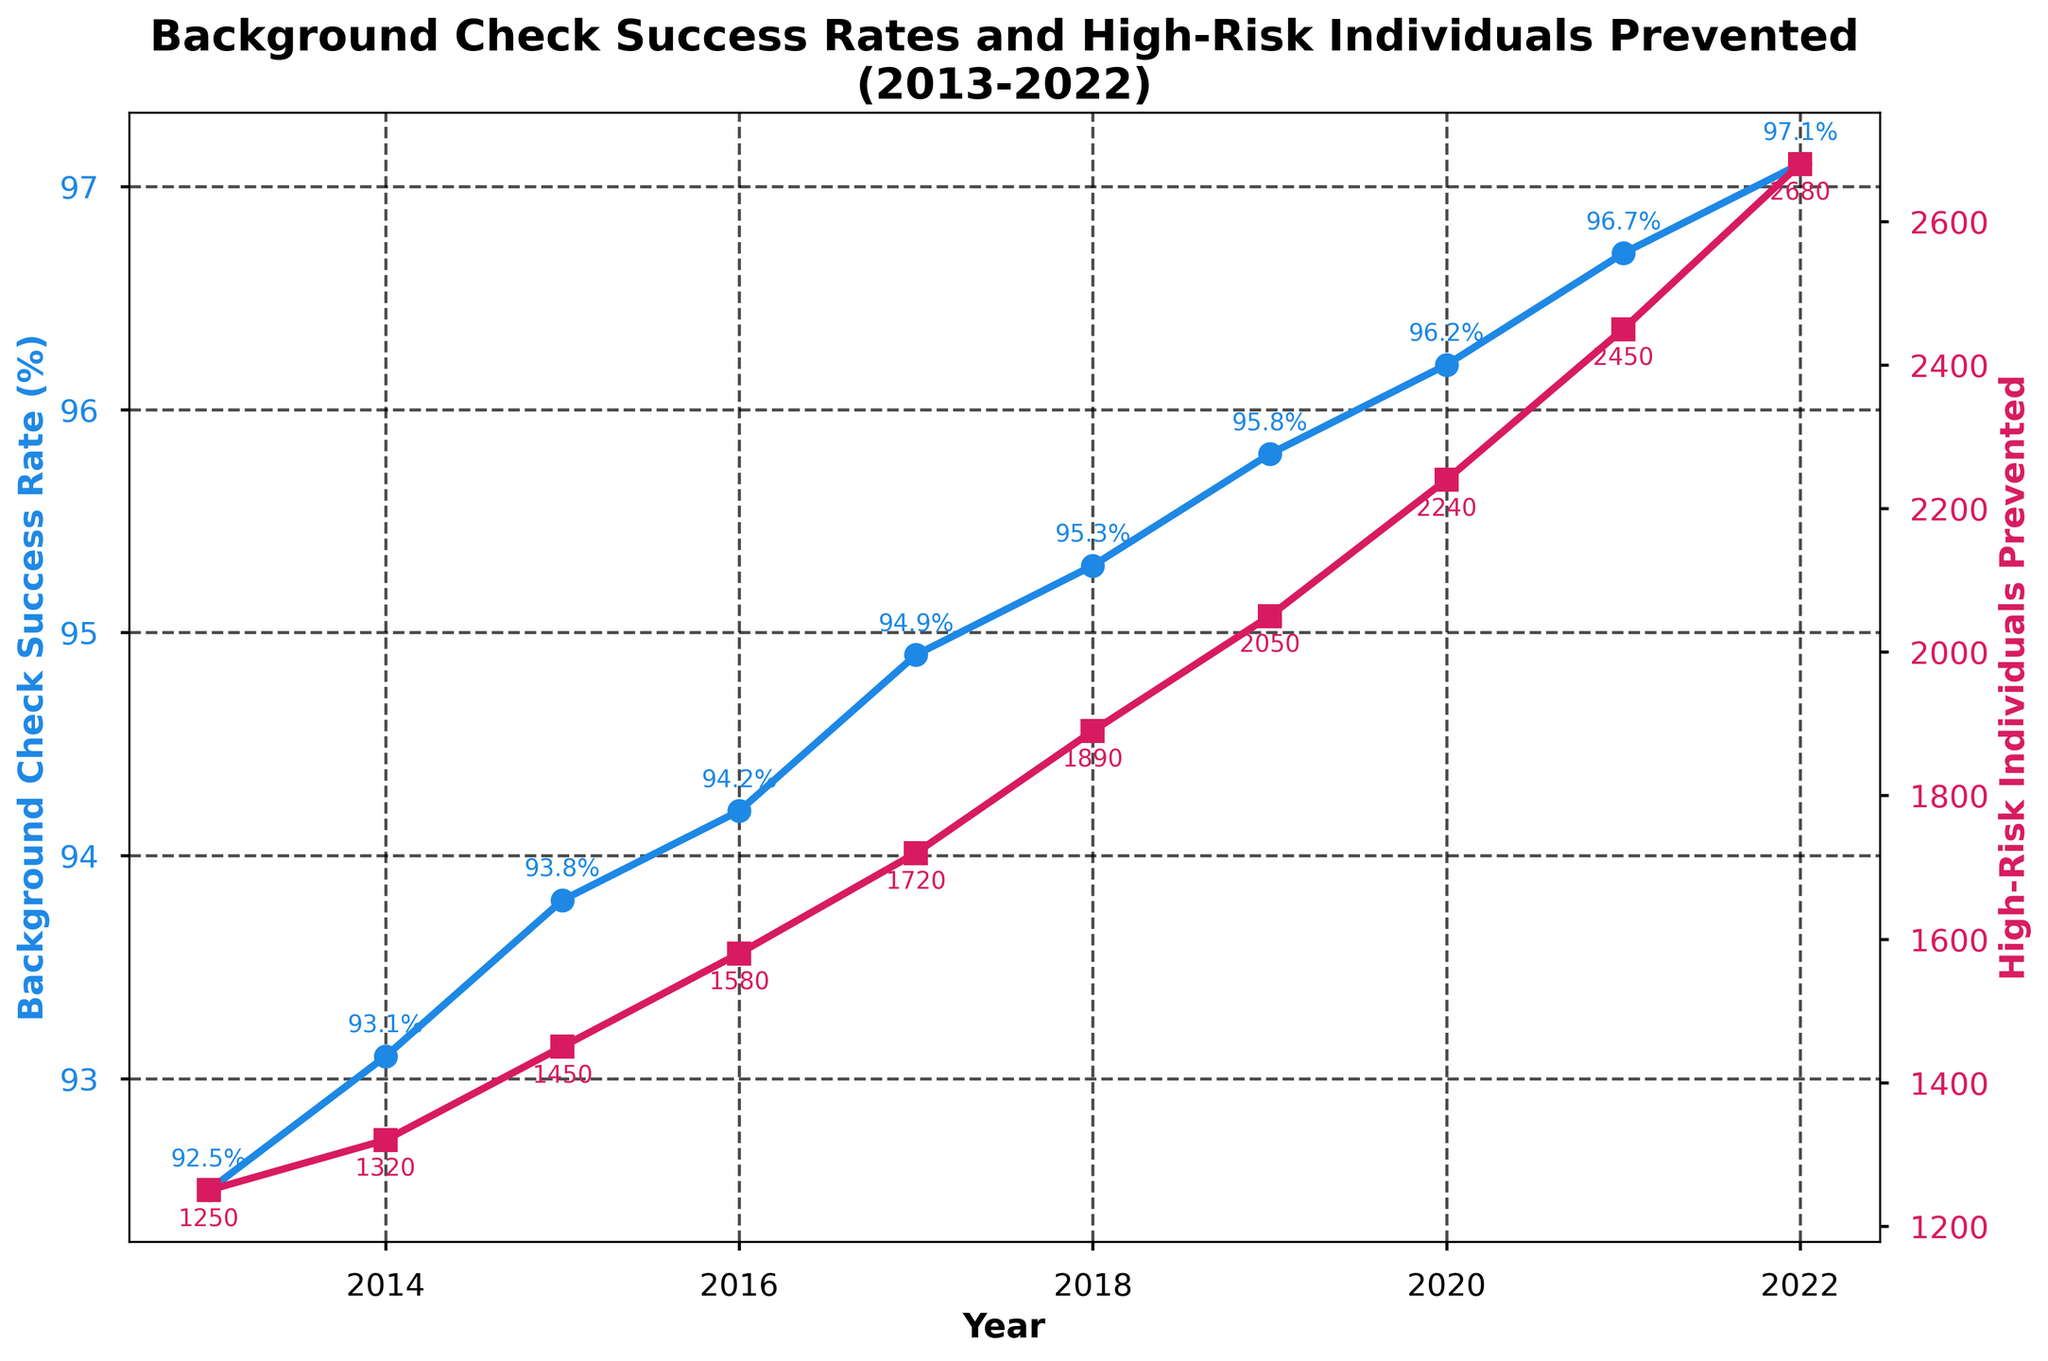What was the percentage success rate of background checks in 2017? The figure displays the background check success rates for each year marked with a blue line and circular markers. Looking at the year 2017, the success rate is marked by a blue point labeled 94.9%.
Answer: 94.9% How many high-risk individuals were prevented in 2020? The figure also plots the high-risk individuals prevented each year with a red line and square markers. For 2020, the value is indicated as 2240.
Answer: 2240 What was the difference in the number of high-risk individuals prevented between 2018 and 2022? First, identify the number of high-risk individuals prevented in 2018 (1890) and in 2022 (2680) from the red line. The difference is 2680 - 1890.
Answer: 790 How did the total number of high-risk individuals prevented change from 2013 to 2022? Review the red line's values for 2013 (1250) and 2022 (2680). Subtract the 2013 value from the 2022 value: 2680 - 1250.
Answer: Increased by 1430 What can be said about the trend in the success rate percentages from 2013 to 2022? The blue line plotting the success rates shows an upward trend, continuously increasing each year from 92.5% in 2013 to 97.1% in 2022.
Answer: Increasing trend Which year experienced the highest number of high-risk individuals prevented from purchasing guns? Refer to the red line plotting high-risk individuals prevented each year; the highest value is in 2022, marked as 2680.
Answer: 2022 Are there any years where the success rate remained constant? Checking each year's success rate on the blue line, we see that the rate continuously increases every year without remaining constant at any point.
Answer: No How does the percentage change in the background check success rate from 2013 to 2014 compare to the percentage change from 2020 to 2021? Calculate the percentage change for both intervals. For 2013-2014: (93.1 - 92.5)/92.5 * 100 = 0.649%, and for 2020-2021: (96.7 - 96.2)/96.2 * 100 = 0.52%.
Answer: Greater increase from 2013 to 2014 What is the average number of high-risk individuals prevented per year from 2017 to 2022? Add the values from 2017 to 2022 (1720 + 1890 + 2050 + 2240 + 2450 + 2680) and divide by the number of years (6). The sum is 13030, so the average is 13030/6.
Answer: 2171.67 Compare the change in the number of high-risk individuals prevented between the first and the last three years in the dataset. For the first three years (2013-2015): Add 1250, 1320, and 1450 to get 4020. For the last three years (2020-2022): Add 2240, 2450, and 2680 to get 7370. Calculate the difference: 7370 - 4020.
Answer: Increased by 3350 